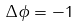<formula> <loc_0><loc_0><loc_500><loc_500>\Delta \phi = - 1</formula> 